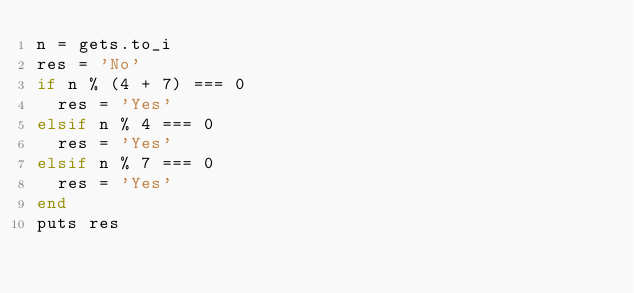<code> <loc_0><loc_0><loc_500><loc_500><_Ruby_>n = gets.to_i
res = 'No'
if n % (4 + 7) === 0
  res = 'Yes'
elsif n % 4 === 0
  res = 'Yes'
elsif n % 7 === 0
  res = 'Yes'
end
puts res</code> 